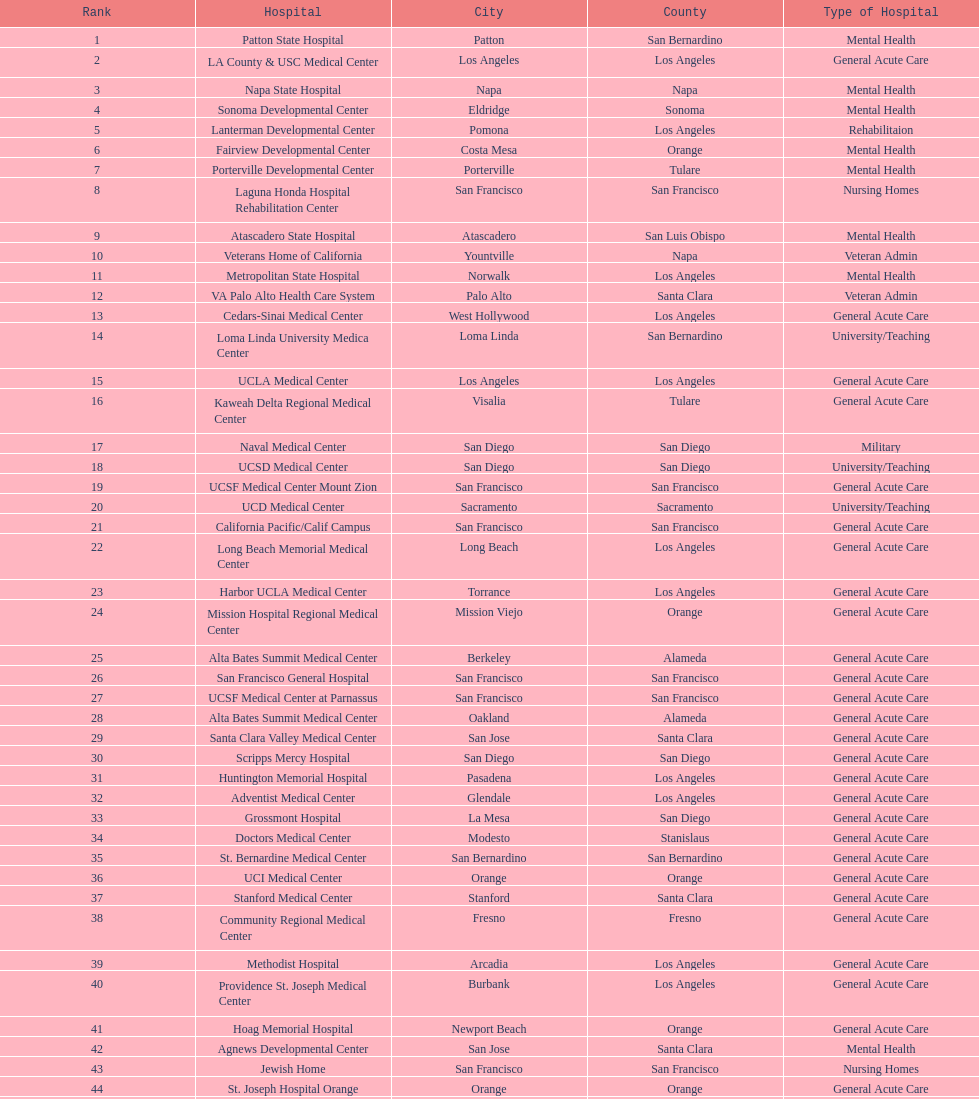Which category of hospitals can be compared to grossmont hospital? General Acute Care. 